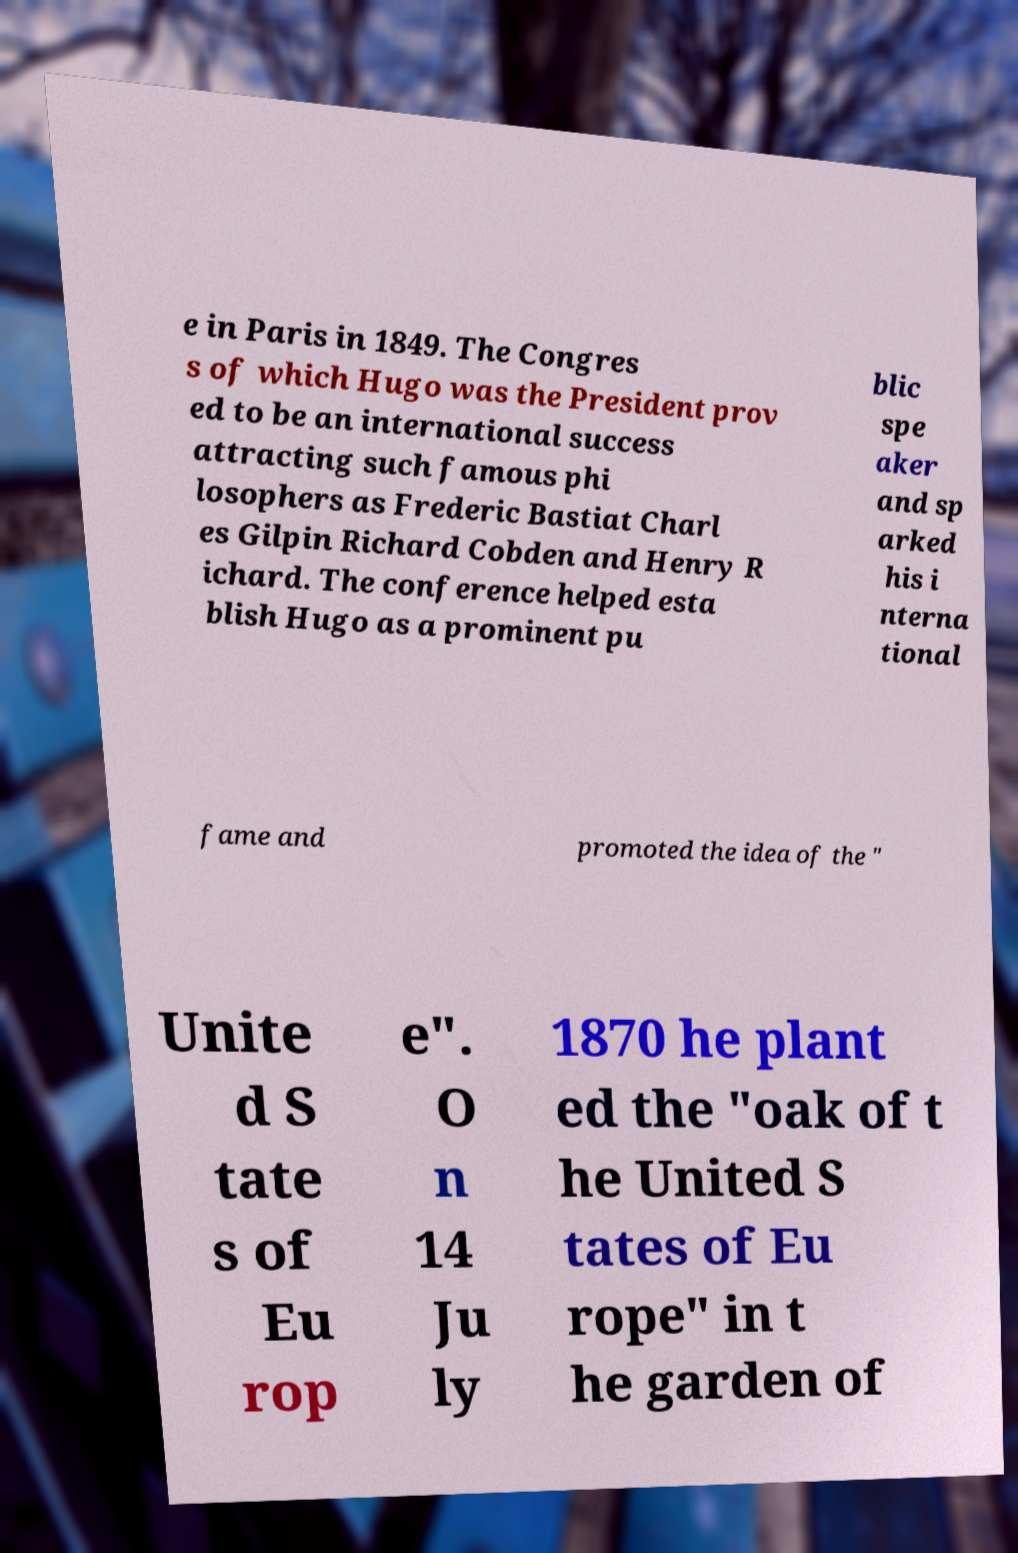What messages or text are displayed in this image? I need them in a readable, typed format. e in Paris in 1849. The Congres s of which Hugo was the President prov ed to be an international success attracting such famous phi losophers as Frederic Bastiat Charl es Gilpin Richard Cobden and Henry R ichard. The conference helped esta blish Hugo as a prominent pu blic spe aker and sp arked his i nterna tional fame and promoted the idea of the " Unite d S tate s of Eu rop e". O n 14 Ju ly 1870 he plant ed the "oak of t he United S tates of Eu rope" in t he garden of 